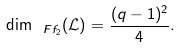Convert formula to latex. <formula><loc_0><loc_0><loc_500><loc_500>\dim _ { \ F f _ { 2 } } ( \mathcal { L } ) = \frac { ( q - 1 ) ^ { 2 } } { 4 } .</formula> 